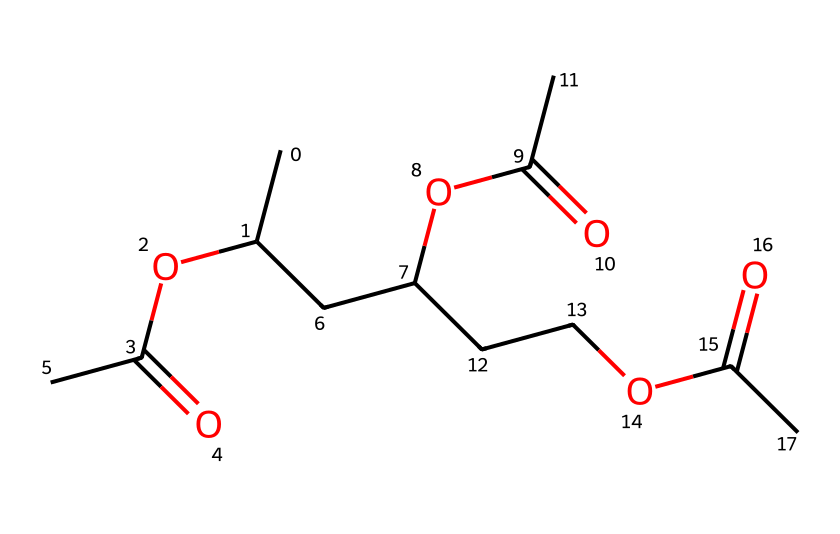How many carbon atoms are present in the chemical structure? By closely examining the SMILES representation, we can identify that each "C" represents a carbon atom. Counting the occurrences of "C" in the SMILES leads to a total of 9 carbon atoms.
Answer: 9 What functional groups can be identified in this structure? The SMILES notation shows multiple "OC(=O)" sequences. This indicates that there are ester functional groups present, as OC(=O) represents an ester linkage.
Answer: esters How many ester groups are present in the polyvinyl acetate structure? The "OC(=O)" appears three times in the SMILES representation, indicating that there are three ester groups integrated into the chemical structure.
Answer: 3 What is the main type of monomer represented by this structure? Given that this structure has a backbone of carbon with ester functionalities, it indicates that this is a polyvinyl monomer, specifically polyvinyl acetate.
Answer: polyvinyl acetate What percentage of the atoms in the molecule are oxygen? In the total atom count, we have 9 carbon atoms, 12 hydrogen atoms, and 3 oxygen atoms. Adding these gives us a total of 24 atoms; thus, the percentage of oxygen atoms is calculated as (3/24) * 100 = 12.5%, rounded down is 12%.
Answer: 12.5% How many hydrogen atoms are present in total? Counting the hydrogen directly in the structure gives 12 hydrogen atoms, as revealed in the SMILES representation where hydrogen atoms are implied based on carbon valency completion.
Answer: 12 